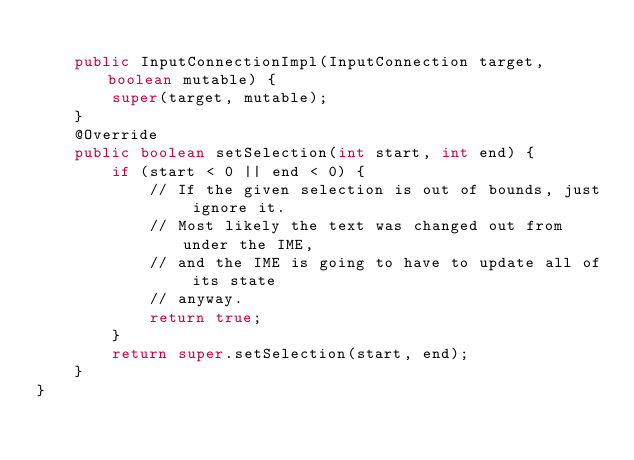Convert code to text. <code><loc_0><loc_0><loc_500><loc_500><_Java_>
    public InputConnectionImpl(InputConnection target, boolean mutable) {
        super(target, mutable);
    }
    @Override
    public boolean setSelection(int start, int end) {
        if (start < 0 || end < 0) {
            // If the given selection is out of bounds, just ignore it.
            // Most likely the text was changed out from under the IME,
            // and the IME is going to have to update all of its state
            // anyway.
            return true;
        }
        return super.setSelection(start, end);
    }
}
</code> 